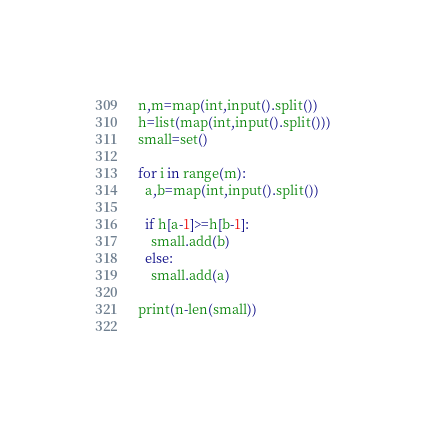<code> <loc_0><loc_0><loc_500><loc_500><_Python_>n,m=map(int,input().split())
h=list(map(int,input().split()))
small=set()

for i in range(m):
  a,b=map(int,input().split())
  
  if h[a-1]>=h[b-1]:
    small.add(b)
  else:
    small.add(a)
    
print(n-len(small))   
    </code> 